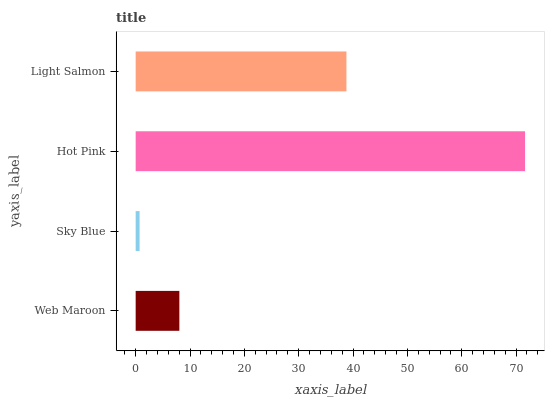Is Sky Blue the minimum?
Answer yes or no. Yes. Is Hot Pink the maximum?
Answer yes or no. Yes. Is Hot Pink the minimum?
Answer yes or no. No. Is Sky Blue the maximum?
Answer yes or no. No. Is Hot Pink greater than Sky Blue?
Answer yes or no. Yes. Is Sky Blue less than Hot Pink?
Answer yes or no. Yes. Is Sky Blue greater than Hot Pink?
Answer yes or no. No. Is Hot Pink less than Sky Blue?
Answer yes or no. No. Is Light Salmon the high median?
Answer yes or no. Yes. Is Web Maroon the low median?
Answer yes or no. Yes. Is Hot Pink the high median?
Answer yes or no. No. Is Hot Pink the low median?
Answer yes or no. No. 